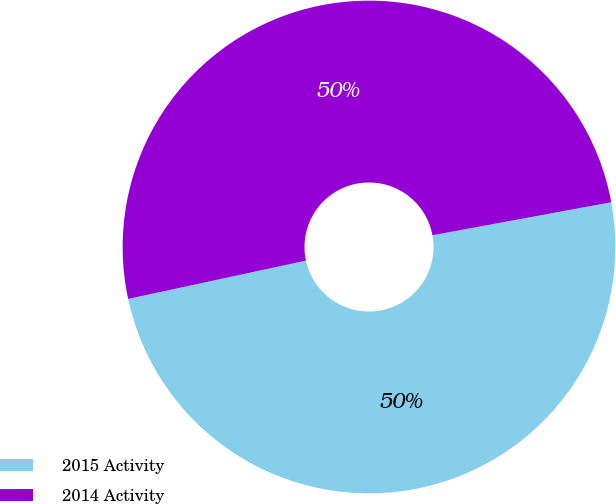Convert chart to OTSL. <chart><loc_0><loc_0><loc_500><loc_500><pie_chart><fcel>2015 Activity<fcel>2014 Activity<nl><fcel>49.53%<fcel>50.47%<nl></chart> 